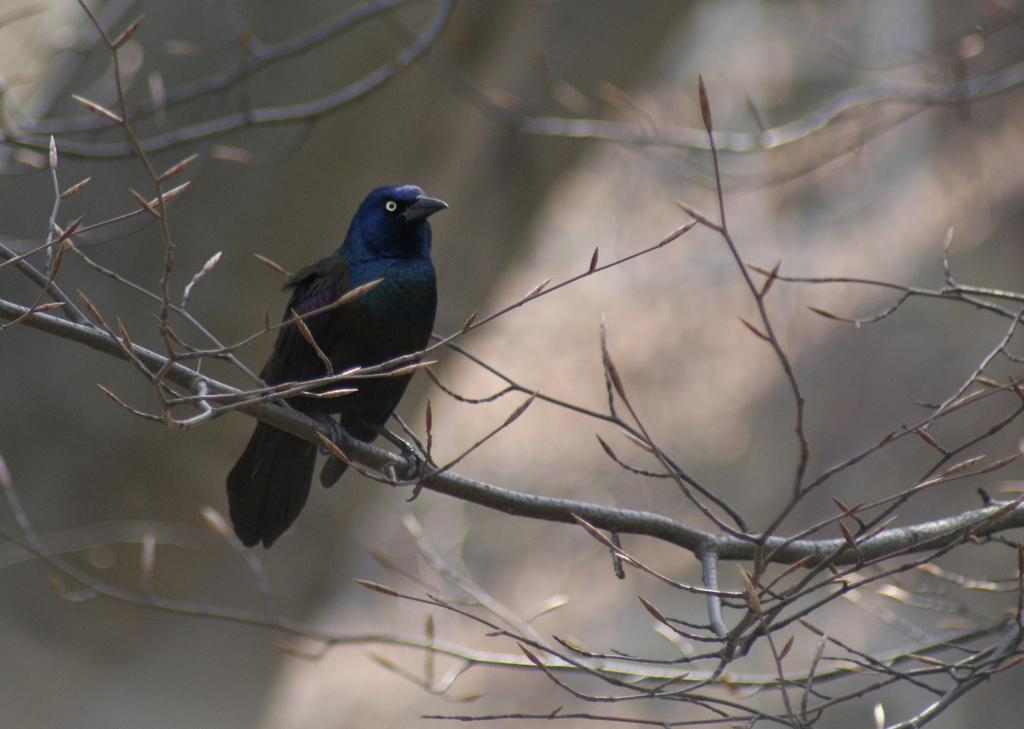What type of animal can be seen in the image? There is a bird in the image. Where is the bird located? The bird is on the branch of a tree. Can you describe the background of the image? The background of the image is blurred. What type of cork can be seen floating in the water near the bird? There is no cork or water present in the image; it features a bird on a tree branch with a blurred background. 